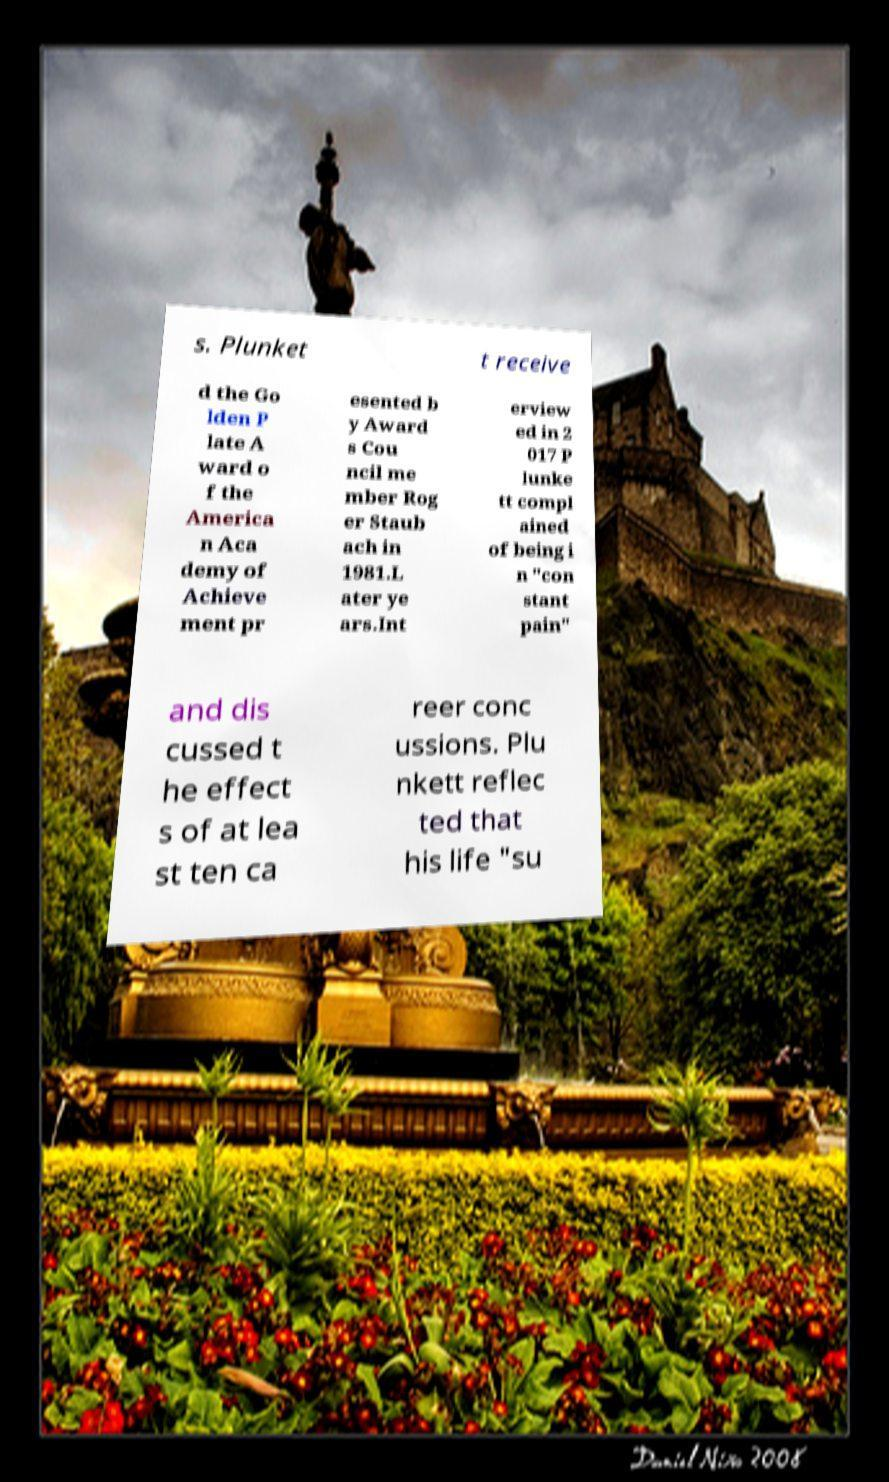What messages or text are displayed in this image? I need them in a readable, typed format. s. Plunket t receive d the Go lden P late A ward o f the America n Aca demy of Achieve ment pr esented b y Award s Cou ncil me mber Rog er Staub ach in 1981.L ater ye ars.Int erview ed in 2 017 P lunke tt compl ained of being i n "con stant pain" and dis cussed t he effect s of at lea st ten ca reer conc ussions. Plu nkett reflec ted that his life "su 